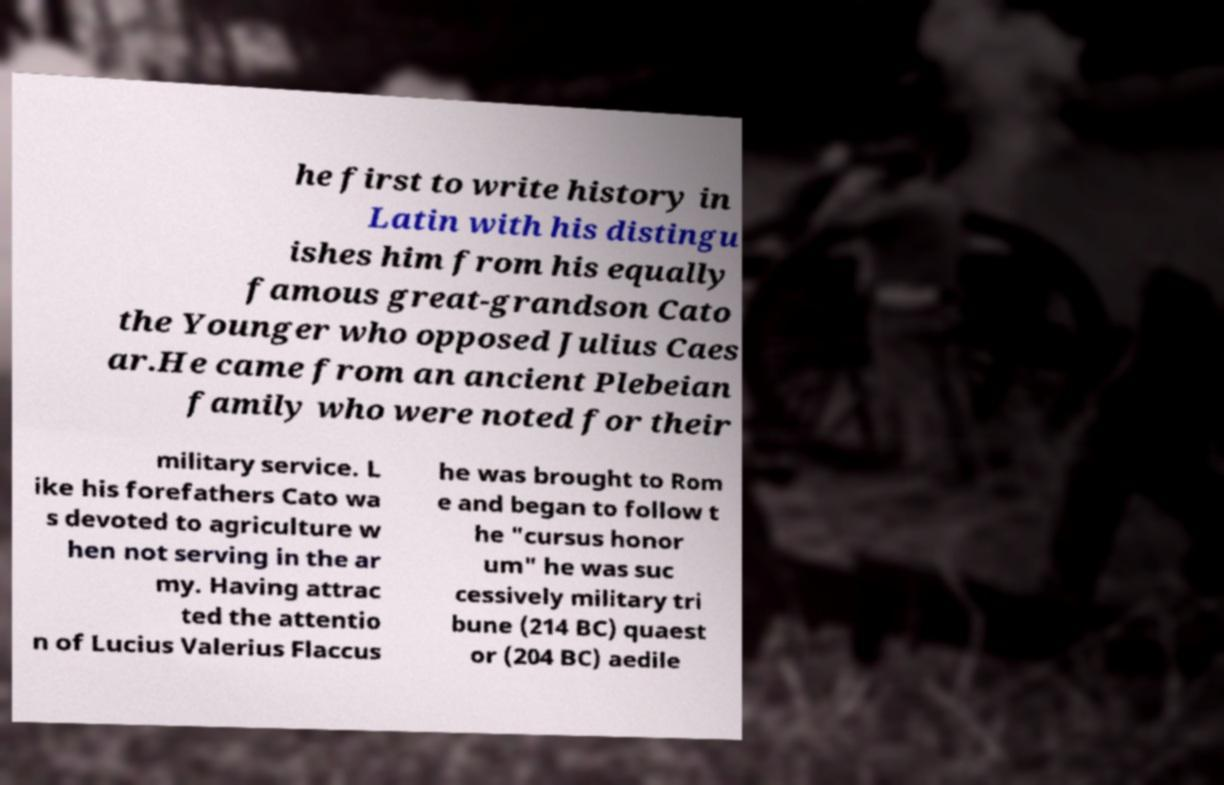Can you accurately transcribe the text from the provided image for me? he first to write history in Latin with his distingu ishes him from his equally famous great-grandson Cato the Younger who opposed Julius Caes ar.He came from an ancient Plebeian family who were noted for their military service. L ike his forefathers Cato wa s devoted to agriculture w hen not serving in the ar my. Having attrac ted the attentio n of Lucius Valerius Flaccus he was brought to Rom e and began to follow t he "cursus honor um" he was suc cessively military tri bune (214 BC) quaest or (204 BC) aedile 